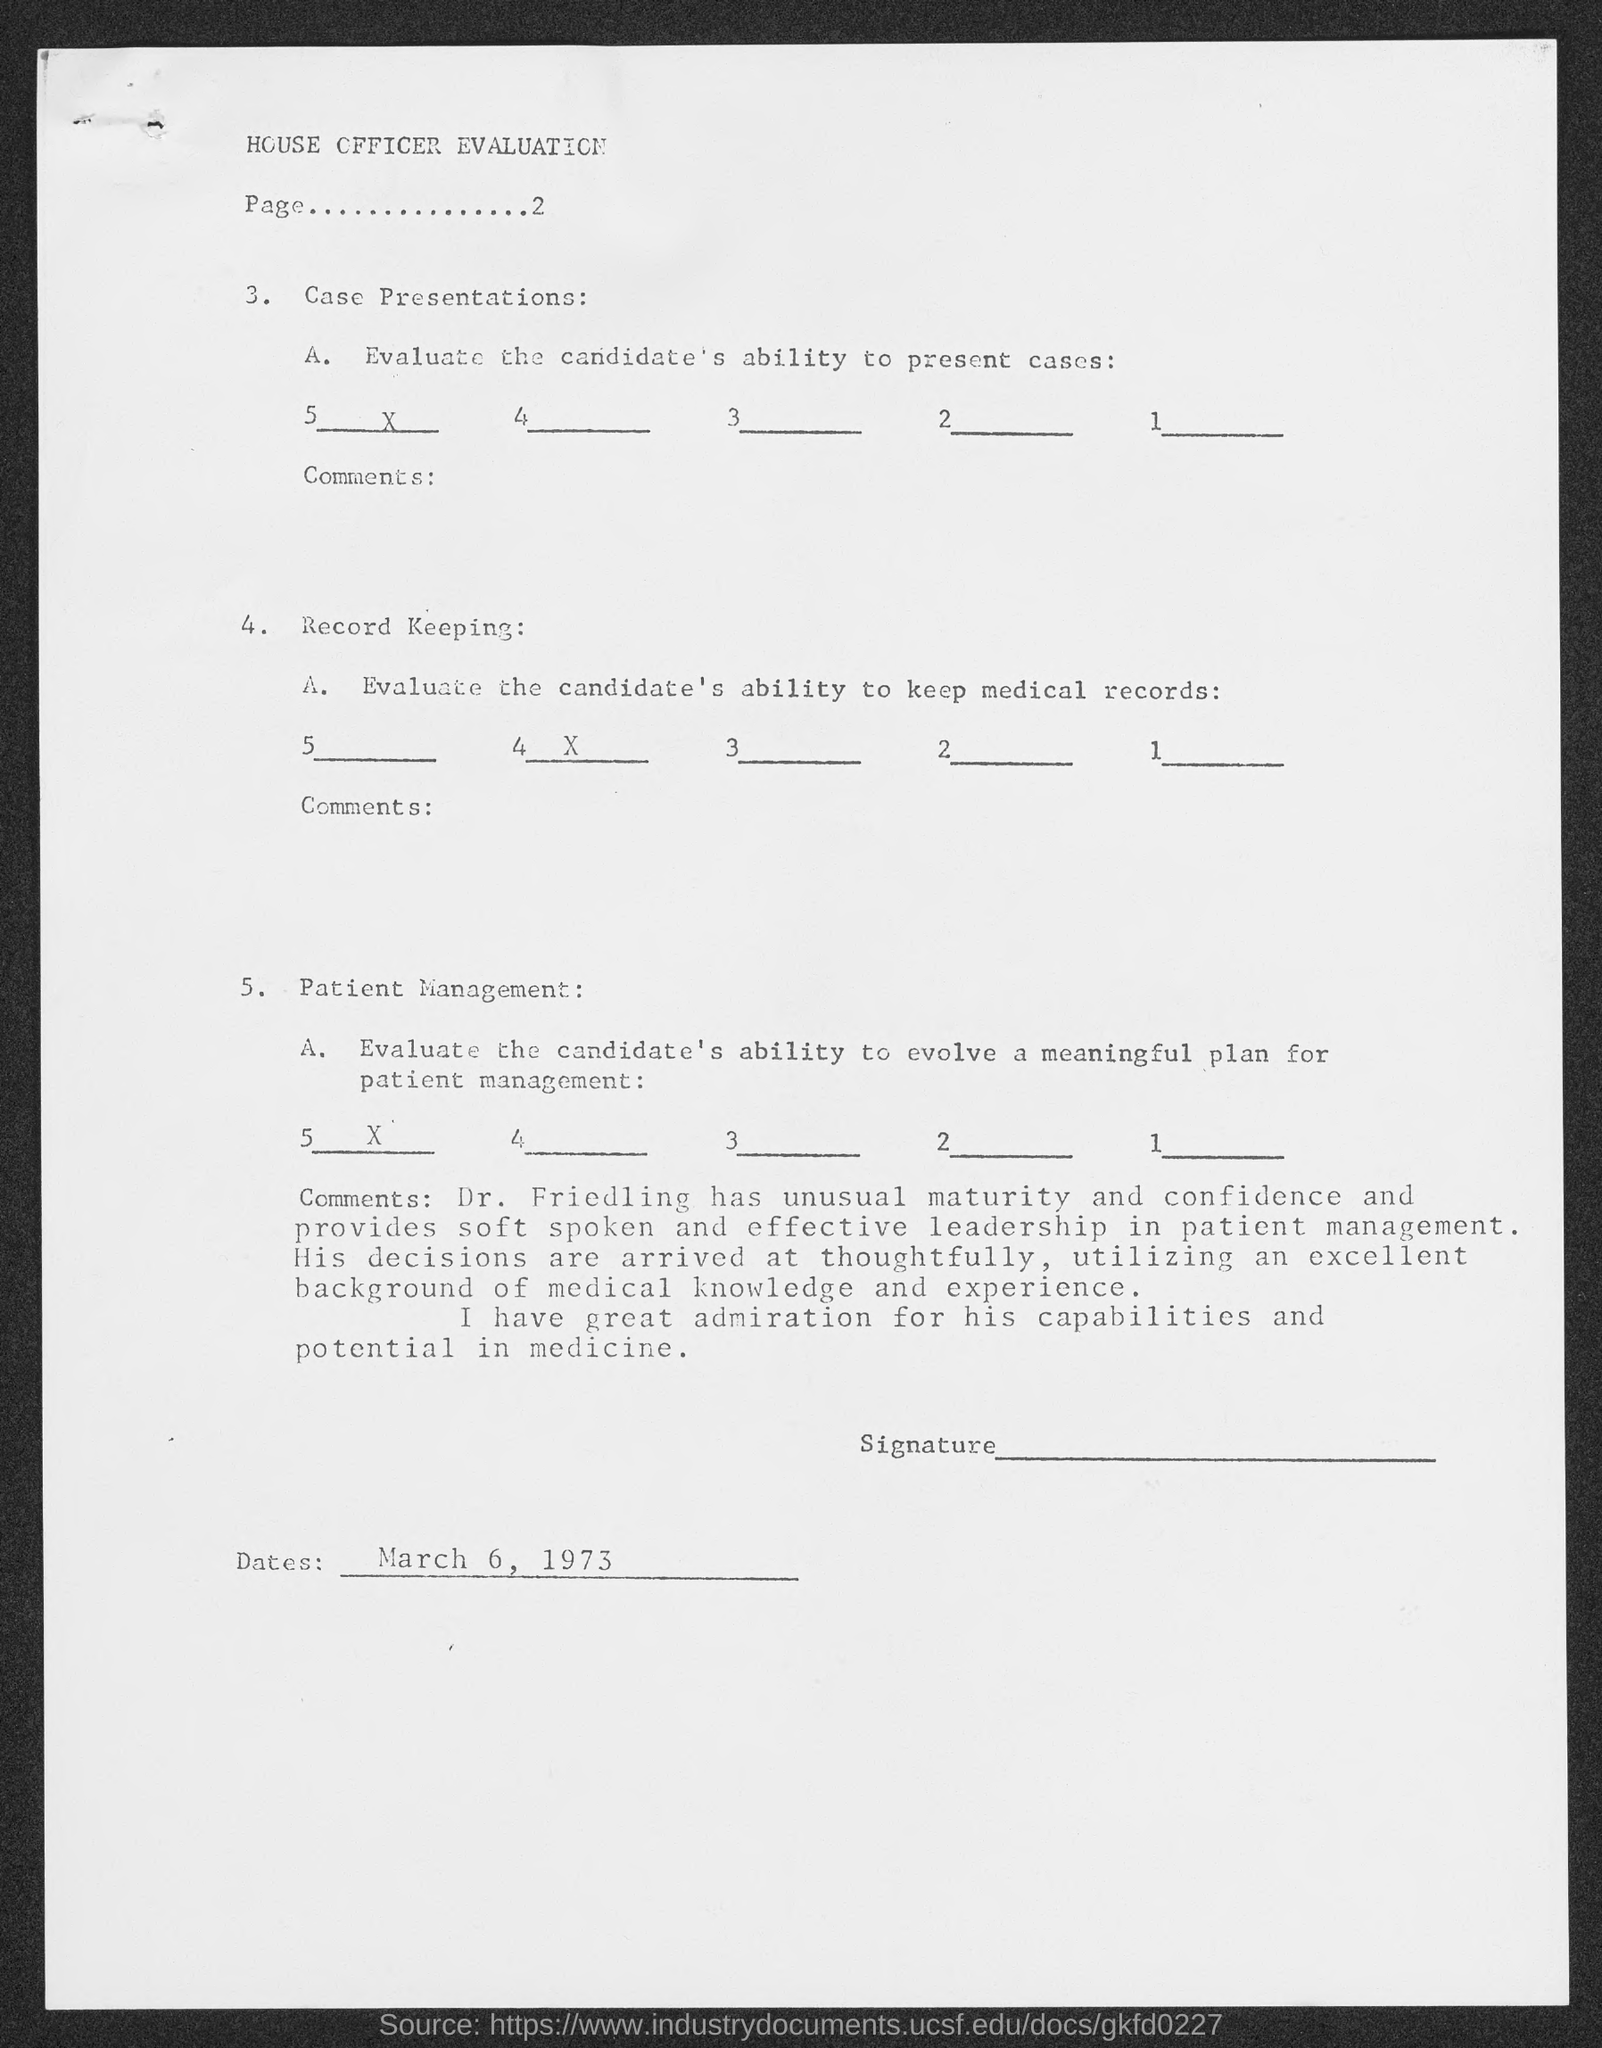What is the date mentioned in the given page ?
Your response must be concise. March 6, 1973. 